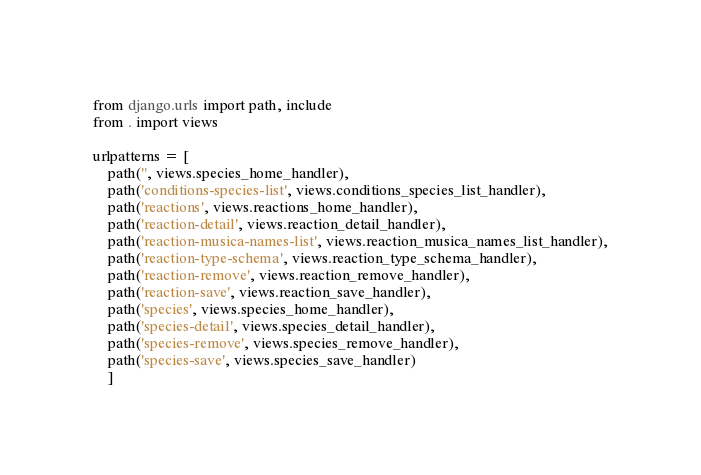Convert code to text. <code><loc_0><loc_0><loc_500><loc_500><_Python_>from django.urls import path, include
from . import views

urlpatterns = [
    path('', views.species_home_handler),
    path('conditions-species-list', views.conditions_species_list_handler),
    path('reactions', views.reactions_home_handler),
    path('reaction-detail', views.reaction_detail_handler),
    path('reaction-musica-names-list', views.reaction_musica_names_list_handler),
    path('reaction-type-schema', views.reaction_type_schema_handler),
    path('reaction-remove', views.reaction_remove_handler),
    path('reaction-save', views.reaction_save_handler),
    path('species', views.species_home_handler),
    path('species-detail', views.species_detail_handler),
    path('species-remove', views.species_remove_handler),
    path('species-save', views.species_save_handler)
    ]
</code> 